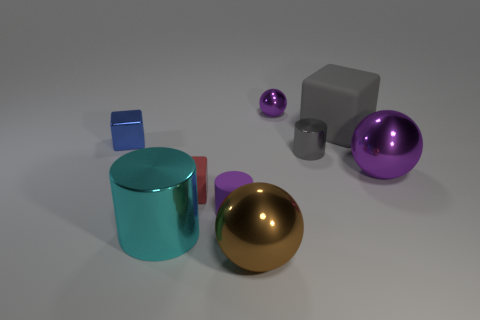Subtract all tiny shiny cubes. How many cubes are left? 2 Subtract all purple balls. How many balls are left? 1 Subtract all cylinders. How many objects are left? 6 Subtract 0 yellow cylinders. How many objects are left? 9 Subtract 3 cylinders. How many cylinders are left? 0 Subtract all cyan cylinders. Subtract all yellow balls. How many cylinders are left? 2 Subtract all cyan blocks. How many brown spheres are left? 1 Subtract all tiny green metal blocks. Subtract all purple rubber objects. How many objects are left? 8 Add 7 large brown metallic spheres. How many large brown metallic spheres are left? 8 Add 1 big balls. How many big balls exist? 3 